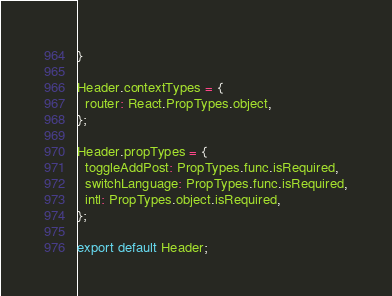Convert code to text. <code><loc_0><loc_0><loc_500><loc_500><_JavaScript_>}

Header.contextTypes = {
  router: React.PropTypes.object,
};

Header.propTypes = {
  toggleAddPost: PropTypes.func.isRequired,
  switchLanguage: PropTypes.func.isRequired,
  intl: PropTypes.object.isRequired,
};

export default Header;
</code> 